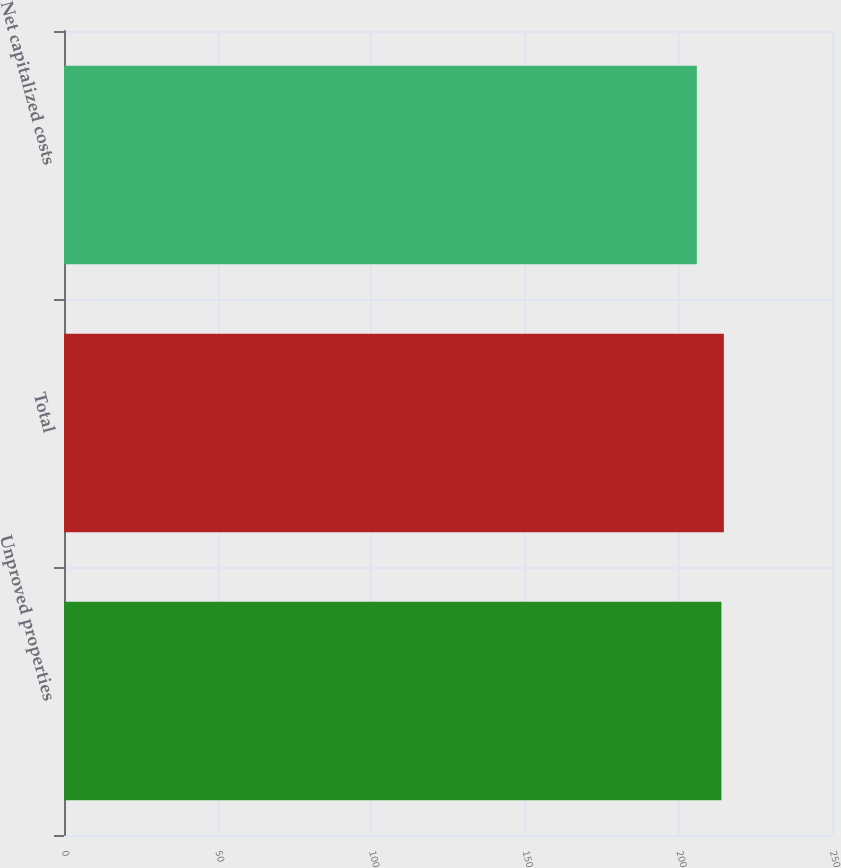Convert chart. <chart><loc_0><loc_0><loc_500><loc_500><bar_chart><fcel>Unproved properties<fcel>Total<fcel>Net capitalized costs<nl><fcel>214<fcel>214.8<fcel>206<nl></chart> 